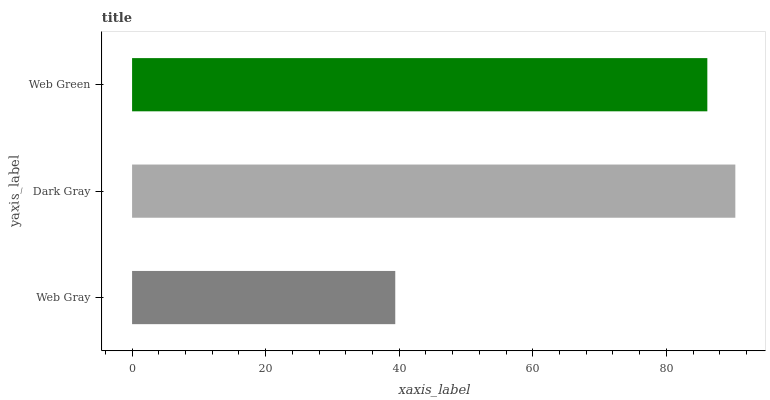Is Web Gray the minimum?
Answer yes or no. Yes. Is Dark Gray the maximum?
Answer yes or no. Yes. Is Web Green the minimum?
Answer yes or no. No. Is Web Green the maximum?
Answer yes or no. No. Is Dark Gray greater than Web Green?
Answer yes or no. Yes. Is Web Green less than Dark Gray?
Answer yes or no. Yes. Is Web Green greater than Dark Gray?
Answer yes or no. No. Is Dark Gray less than Web Green?
Answer yes or no. No. Is Web Green the high median?
Answer yes or no. Yes. Is Web Green the low median?
Answer yes or no. Yes. Is Web Gray the high median?
Answer yes or no. No. Is Dark Gray the low median?
Answer yes or no. No. 